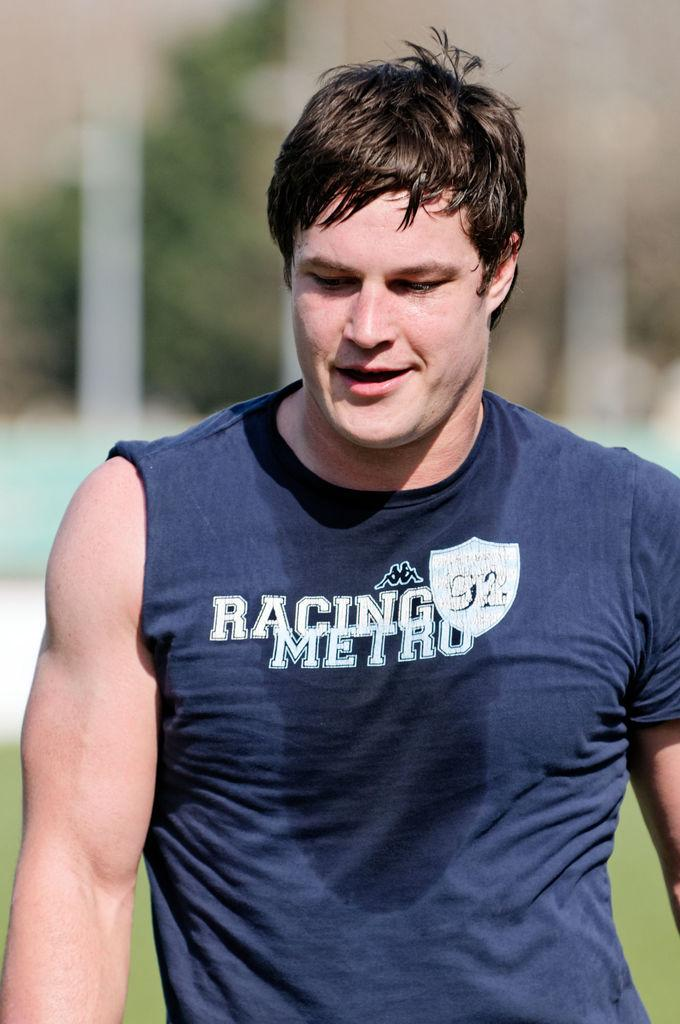<image>
Write a terse but informative summary of the picture. A sweaty man with a blue Racing Metro walks looking down at the ground. 